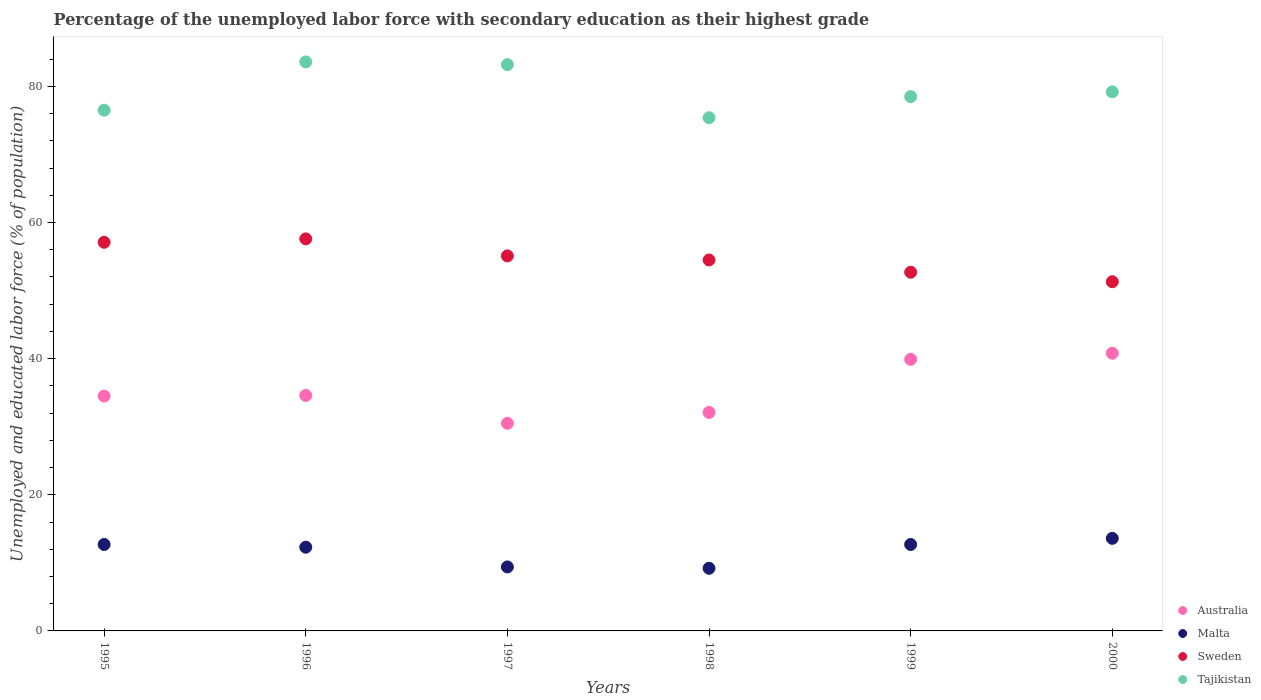How many different coloured dotlines are there?
Provide a succinct answer. 4. What is the percentage of the unemployed labor force with secondary education in Australia in 1997?
Your response must be concise. 30.5. Across all years, what is the maximum percentage of the unemployed labor force with secondary education in Australia?
Make the answer very short. 40.8. Across all years, what is the minimum percentage of the unemployed labor force with secondary education in Tajikistan?
Your answer should be very brief. 75.4. In which year was the percentage of the unemployed labor force with secondary education in Malta maximum?
Provide a succinct answer. 2000. What is the total percentage of the unemployed labor force with secondary education in Tajikistan in the graph?
Your response must be concise. 476.4. What is the difference between the percentage of the unemployed labor force with secondary education in Malta in 1996 and that in 1998?
Your answer should be compact. 3.1. What is the difference between the percentage of the unemployed labor force with secondary education in Tajikistan in 1998 and the percentage of the unemployed labor force with secondary education in Australia in 1997?
Your answer should be compact. 44.9. What is the average percentage of the unemployed labor force with secondary education in Tajikistan per year?
Ensure brevity in your answer.  79.4. In the year 1997, what is the difference between the percentage of the unemployed labor force with secondary education in Sweden and percentage of the unemployed labor force with secondary education in Australia?
Your answer should be very brief. 24.6. In how many years, is the percentage of the unemployed labor force with secondary education in Malta greater than 20 %?
Offer a very short reply. 0. What is the ratio of the percentage of the unemployed labor force with secondary education in Australia in 1995 to that in 1997?
Provide a short and direct response. 1.13. Is the difference between the percentage of the unemployed labor force with secondary education in Sweden in 1996 and 1997 greater than the difference between the percentage of the unemployed labor force with secondary education in Australia in 1996 and 1997?
Your answer should be compact. No. What is the difference between the highest and the second highest percentage of the unemployed labor force with secondary education in Malta?
Ensure brevity in your answer.  0.9. What is the difference between the highest and the lowest percentage of the unemployed labor force with secondary education in Sweden?
Offer a terse response. 6.3. In how many years, is the percentage of the unemployed labor force with secondary education in Sweden greater than the average percentage of the unemployed labor force with secondary education in Sweden taken over all years?
Keep it short and to the point. 3. Is the sum of the percentage of the unemployed labor force with secondary education in Australia in 1995 and 1998 greater than the maximum percentage of the unemployed labor force with secondary education in Sweden across all years?
Offer a terse response. Yes. Is it the case that in every year, the sum of the percentage of the unemployed labor force with secondary education in Australia and percentage of the unemployed labor force with secondary education in Malta  is greater than the sum of percentage of the unemployed labor force with secondary education in Tajikistan and percentage of the unemployed labor force with secondary education in Sweden?
Ensure brevity in your answer.  No. Is it the case that in every year, the sum of the percentage of the unemployed labor force with secondary education in Australia and percentage of the unemployed labor force with secondary education in Tajikistan  is greater than the percentage of the unemployed labor force with secondary education in Sweden?
Provide a succinct answer. Yes. Is the percentage of the unemployed labor force with secondary education in Sweden strictly less than the percentage of the unemployed labor force with secondary education in Malta over the years?
Provide a succinct answer. No. How many dotlines are there?
Give a very brief answer. 4. Does the graph contain grids?
Give a very brief answer. No. How are the legend labels stacked?
Provide a short and direct response. Vertical. What is the title of the graph?
Give a very brief answer. Percentage of the unemployed labor force with secondary education as their highest grade. What is the label or title of the X-axis?
Make the answer very short. Years. What is the label or title of the Y-axis?
Your answer should be compact. Unemployed and educated labor force (% of population). What is the Unemployed and educated labor force (% of population) of Australia in 1995?
Your answer should be very brief. 34.5. What is the Unemployed and educated labor force (% of population) of Malta in 1995?
Your response must be concise. 12.7. What is the Unemployed and educated labor force (% of population) of Sweden in 1995?
Offer a terse response. 57.1. What is the Unemployed and educated labor force (% of population) in Tajikistan in 1995?
Give a very brief answer. 76.5. What is the Unemployed and educated labor force (% of population) in Australia in 1996?
Provide a short and direct response. 34.6. What is the Unemployed and educated labor force (% of population) of Malta in 1996?
Your answer should be compact. 12.3. What is the Unemployed and educated labor force (% of population) of Sweden in 1996?
Offer a terse response. 57.6. What is the Unemployed and educated labor force (% of population) in Tajikistan in 1996?
Make the answer very short. 83.6. What is the Unemployed and educated labor force (% of population) of Australia in 1997?
Give a very brief answer. 30.5. What is the Unemployed and educated labor force (% of population) in Malta in 1997?
Provide a succinct answer. 9.4. What is the Unemployed and educated labor force (% of population) in Sweden in 1997?
Your response must be concise. 55.1. What is the Unemployed and educated labor force (% of population) in Tajikistan in 1997?
Give a very brief answer. 83.2. What is the Unemployed and educated labor force (% of population) of Australia in 1998?
Your response must be concise. 32.1. What is the Unemployed and educated labor force (% of population) of Malta in 1998?
Provide a succinct answer. 9.2. What is the Unemployed and educated labor force (% of population) of Sweden in 1998?
Your response must be concise. 54.5. What is the Unemployed and educated labor force (% of population) of Tajikistan in 1998?
Keep it short and to the point. 75.4. What is the Unemployed and educated labor force (% of population) of Australia in 1999?
Provide a succinct answer. 39.9. What is the Unemployed and educated labor force (% of population) of Malta in 1999?
Keep it short and to the point. 12.7. What is the Unemployed and educated labor force (% of population) of Sweden in 1999?
Your answer should be compact. 52.7. What is the Unemployed and educated labor force (% of population) in Tajikistan in 1999?
Your answer should be very brief. 78.5. What is the Unemployed and educated labor force (% of population) in Australia in 2000?
Provide a succinct answer. 40.8. What is the Unemployed and educated labor force (% of population) in Malta in 2000?
Provide a succinct answer. 13.6. What is the Unemployed and educated labor force (% of population) in Sweden in 2000?
Provide a succinct answer. 51.3. What is the Unemployed and educated labor force (% of population) of Tajikistan in 2000?
Give a very brief answer. 79.2. Across all years, what is the maximum Unemployed and educated labor force (% of population) in Australia?
Provide a short and direct response. 40.8. Across all years, what is the maximum Unemployed and educated labor force (% of population) of Malta?
Keep it short and to the point. 13.6. Across all years, what is the maximum Unemployed and educated labor force (% of population) in Sweden?
Make the answer very short. 57.6. Across all years, what is the maximum Unemployed and educated labor force (% of population) of Tajikistan?
Ensure brevity in your answer.  83.6. Across all years, what is the minimum Unemployed and educated labor force (% of population) in Australia?
Your answer should be compact. 30.5. Across all years, what is the minimum Unemployed and educated labor force (% of population) of Malta?
Your answer should be very brief. 9.2. Across all years, what is the minimum Unemployed and educated labor force (% of population) of Sweden?
Give a very brief answer. 51.3. Across all years, what is the minimum Unemployed and educated labor force (% of population) in Tajikistan?
Offer a very short reply. 75.4. What is the total Unemployed and educated labor force (% of population) of Australia in the graph?
Keep it short and to the point. 212.4. What is the total Unemployed and educated labor force (% of population) in Malta in the graph?
Offer a terse response. 69.9. What is the total Unemployed and educated labor force (% of population) in Sweden in the graph?
Offer a very short reply. 328.3. What is the total Unemployed and educated labor force (% of population) in Tajikistan in the graph?
Offer a very short reply. 476.4. What is the difference between the Unemployed and educated labor force (% of population) of Malta in 1995 and that in 1996?
Ensure brevity in your answer.  0.4. What is the difference between the Unemployed and educated labor force (% of population) of Sweden in 1995 and that in 1997?
Make the answer very short. 2. What is the difference between the Unemployed and educated labor force (% of population) in Tajikistan in 1995 and that in 1997?
Your response must be concise. -6.7. What is the difference between the Unemployed and educated labor force (% of population) of Australia in 1995 and that in 1998?
Ensure brevity in your answer.  2.4. What is the difference between the Unemployed and educated labor force (% of population) of Malta in 1995 and that in 1998?
Your answer should be very brief. 3.5. What is the difference between the Unemployed and educated labor force (% of population) in Sweden in 1995 and that in 1998?
Your answer should be very brief. 2.6. What is the difference between the Unemployed and educated labor force (% of population) of Australia in 1995 and that in 1999?
Offer a terse response. -5.4. What is the difference between the Unemployed and educated labor force (% of population) in Sweden in 1995 and that in 1999?
Give a very brief answer. 4.4. What is the difference between the Unemployed and educated labor force (% of population) of Tajikistan in 1995 and that in 1999?
Offer a terse response. -2. What is the difference between the Unemployed and educated labor force (% of population) in Malta in 1995 and that in 2000?
Keep it short and to the point. -0.9. What is the difference between the Unemployed and educated labor force (% of population) in Tajikistan in 1995 and that in 2000?
Offer a terse response. -2.7. What is the difference between the Unemployed and educated labor force (% of population) in Malta in 1996 and that in 1997?
Provide a succinct answer. 2.9. What is the difference between the Unemployed and educated labor force (% of population) in Sweden in 1996 and that in 1997?
Make the answer very short. 2.5. What is the difference between the Unemployed and educated labor force (% of population) in Malta in 1996 and that in 1998?
Offer a very short reply. 3.1. What is the difference between the Unemployed and educated labor force (% of population) in Sweden in 1996 and that in 1998?
Provide a succinct answer. 3.1. What is the difference between the Unemployed and educated labor force (% of population) in Tajikistan in 1996 and that in 1998?
Provide a short and direct response. 8.2. What is the difference between the Unemployed and educated labor force (% of population) of Malta in 1996 and that in 1999?
Your answer should be very brief. -0.4. What is the difference between the Unemployed and educated labor force (% of population) of Sweden in 1996 and that in 1999?
Offer a very short reply. 4.9. What is the difference between the Unemployed and educated labor force (% of population) of Tajikistan in 1996 and that in 1999?
Offer a terse response. 5.1. What is the difference between the Unemployed and educated labor force (% of population) in Australia in 1996 and that in 2000?
Make the answer very short. -6.2. What is the difference between the Unemployed and educated labor force (% of population) in Malta in 1996 and that in 2000?
Give a very brief answer. -1.3. What is the difference between the Unemployed and educated labor force (% of population) of Tajikistan in 1996 and that in 2000?
Provide a short and direct response. 4.4. What is the difference between the Unemployed and educated labor force (% of population) in Australia in 1997 and that in 1998?
Your answer should be very brief. -1.6. What is the difference between the Unemployed and educated labor force (% of population) of Sweden in 1997 and that in 1998?
Ensure brevity in your answer.  0.6. What is the difference between the Unemployed and educated labor force (% of population) of Tajikistan in 1997 and that in 1998?
Offer a very short reply. 7.8. What is the difference between the Unemployed and educated labor force (% of population) in Australia in 1997 and that in 1999?
Offer a very short reply. -9.4. What is the difference between the Unemployed and educated labor force (% of population) of Tajikistan in 1997 and that in 1999?
Offer a terse response. 4.7. What is the difference between the Unemployed and educated labor force (% of population) of Tajikistan in 1997 and that in 2000?
Give a very brief answer. 4. What is the difference between the Unemployed and educated labor force (% of population) of Australia in 1998 and that in 1999?
Offer a terse response. -7.8. What is the difference between the Unemployed and educated labor force (% of population) in Australia in 1998 and that in 2000?
Offer a very short reply. -8.7. What is the difference between the Unemployed and educated labor force (% of population) in Sweden in 1998 and that in 2000?
Ensure brevity in your answer.  3.2. What is the difference between the Unemployed and educated labor force (% of population) in Australia in 1999 and that in 2000?
Offer a terse response. -0.9. What is the difference between the Unemployed and educated labor force (% of population) of Malta in 1999 and that in 2000?
Ensure brevity in your answer.  -0.9. What is the difference between the Unemployed and educated labor force (% of population) of Australia in 1995 and the Unemployed and educated labor force (% of population) of Malta in 1996?
Keep it short and to the point. 22.2. What is the difference between the Unemployed and educated labor force (% of population) in Australia in 1995 and the Unemployed and educated labor force (% of population) in Sweden in 1996?
Make the answer very short. -23.1. What is the difference between the Unemployed and educated labor force (% of population) in Australia in 1995 and the Unemployed and educated labor force (% of population) in Tajikistan in 1996?
Offer a very short reply. -49.1. What is the difference between the Unemployed and educated labor force (% of population) in Malta in 1995 and the Unemployed and educated labor force (% of population) in Sweden in 1996?
Offer a very short reply. -44.9. What is the difference between the Unemployed and educated labor force (% of population) of Malta in 1995 and the Unemployed and educated labor force (% of population) of Tajikistan in 1996?
Ensure brevity in your answer.  -70.9. What is the difference between the Unemployed and educated labor force (% of population) of Sweden in 1995 and the Unemployed and educated labor force (% of population) of Tajikistan in 1996?
Your answer should be compact. -26.5. What is the difference between the Unemployed and educated labor force (% of population) in Australia in 1995 and the Unemployed and educated labor force (% of population) in Malta in 1997?
Ensure brevity in your answer.  25.1. What is the difference between the Unemployed and educated labor force (% of population) in Australia in 1995 and the Unemployed and educated labor force (% of population) in Sweden in 1997?
Give a very brief answer. -20.6. What is the difference between the Unemployed and educated labor force (% of population) of Australia in 1995 and the Unemployed and educated labor force (% of population) of Tajikistan in 1997?
Your response must be concise. -48.7. What is the difference between the Unemployed and educated labor force (% of population) of Malta in 1995 and the Unemployed and educated labor force (% of population) of Sweden in 1997?
Keep it short and to the point. -42.4. What is the difference between the Unemployed and educated labor force (% of population) in Malta in 1995 and the Unemployed and educated labor force (% of population) in Tajikistan in 1997?
Provide a succinct answer. -70.5. What is the difference between the Unemployed and educated labor force (% of population) of Sweden in 1995 and the Unemployed and educated labor force (% of population) of Tajikistan in 1997?
Offer a very short reply. -26.1. What is the difference between the Unemployed and educated labor force (% of population) of Australia in 1995 and the Unemployed and educated labor force (% of population) of Malta in 1998?
Give a very brief answer. 25.3. What is the difference between the Unemployed and educated labor force (% of population) of Australia in 1995 and the Unemployed and educated labor force (% of population) of Sweden in 1998?
Your answer should be very brief. -20. What is the difference between the Unemployed and educated labor force (% of population) of Australia in 1995 and the Unemployed and educated labor force (% of population) of Tajikistan in 1998?
Keep it short and to the point. -40.9. What is the difference between the Unemployed and educated labor force (% of population) in Malta in 1995 and the Unemployed and educated labor force (% of population) in Sweden in 1998?
Give a very brief answer. -41.8. What is the difference between the Unemployed and educated labor force (% of population) of Malta in 1995 and the Unemployed and educated labor force (% of population) of Tajikistan in 1998?
Offer a terse response. -62.7. What is the difference between the Unemployed and educated labor force (% of population) in Sweden in 1995 and the Unemployed and educated labor force (% of population) in Tajikistan in 1998?
Offer a very short reply. -18.3. What is the difference between the Unemployed and educated labor force (% of population) in Australia in 1995 and the Unemployed and educated labor force (% of population) in Malta in 1999?
Offer a very short reply. 21.8. What is the difference between the Unemployed and educated labor force (% of population) of Australia in 1995 and the Unemployed and educated labor force (% of population) of Sweden in 1999?
Keep it short and to the point. -18.2. What is the difference between the Unemployed and educated labor force (% of population) in Australia in 1995 and the Unemployed and educated labor force (% of population) in Tajikistan in 1999?
Offer a very short reply. -44. What is the difference between the Unemployed and educated labor force (% of population) of Malta in 1995 and the Unemployed and educated labor force (% of population) of Sweden in 1999?
Provide a short and direct response. -40. What is the difference between the Unemployed and educated labor force (% of population) in Malta in 1995 and the Unemployed and educated labor force (% of population) in Tajikistan in 1999?
Make the answer very short. -65.8. What is the difference between the Unemployed and educated labor force (% of population) in Sweden in 1995 and the Unemployed and educated labor force (% of population) in Tajikistan in 1999?
Keep it short and to the point. -21.4. What is the difference between the Unemployed and educated labor force (% of population) of Australia in 1995 and the Unemployed and educated labor force (% of population) of Malta in 2000?
Make the answer very short. 20.9. What is the difference between the Unemployed and educated labor force (% of population) in Australia in 1995 and the Unemployed and educated labor force (% of population) in Sweden in 2000?
Your answer should be very brief. -16.8. What is the difference between the Unemployed and educated labor force (% of population) of Australia in 1995 and the Unemployed and educated labor force (% of population) of Tajikistan in 2000?
Your answer should be very brief. -44.7. What is the difference between the Unemployed and educated labor force (% of population) of Malta in 1995 and the Unemployed and educated labor force (% of population) of Sweden in 2000?
Your answer should be very brief. -38.6. What is the difference between the Unemployed and educated labor force (% of population) of Malta in 1995 and the Unemployed and educated labor force (% of population) of Tajikistan in 2000?
Your answer should be very brief. -66.5. What is the difference between the Unemployed and educated labor force (% of population) of Sweden in 1995 and the Unemployed and educated labor force (% of population) of Tajikistan in 2000?
Your response must be concise. -22.1. What is the difference between the Unemployed and educated labor force (% of population) of Australia in 1996 and the Unemployed and educated labor force (% of population) of Malta in 1997?
Give a very brief answer. 25.2. What is the difference between the Unemployed and educated labor force (% of population) in Australia in 1996 and the Unemployed and educated labor force (% of population) in Sweden in 1997?
Your answer should be compact. -20.5. What is the difference between the Unemployed and educated labor force (% of population) of Australia in 1996 and the Unemployed and educated labor force (% of population) of Tajikistan in 1997?
Make the answer very short. -48.6. What is the difference between the Unemployed and educated labor force (% of population) in Malta in 1996 and the Unemployed and educated labor force (% of population) in Sweden in 1997?
Offer a terse response. -42.8. What is the difference between the Unemployed and educated labor force (% of population) in Malta in 1996 and the Unemployed and educated labor force (% of population) in Tajikistan in 1997?
Provide a succinct answer. -70.9. What is the difference between the Unemployed and educated labor force (% of population) of Sweden in 1996 and the Unemployed and educated labor force (% of population) of Tajikistan in 1997?
Provide a succinct answer. -25.6. What is the difference between the Unemployed and educated labor force (% of population) of Australia in 1996 and the Unemployed and educated labor force (% of population) of Malta in 1998?
Provide a succinct answer. 25.4. What is the difference between the Unemployed and educated labor force (% of population) of Australia in 1996 and the Unemployed and educated labor force (% of population) of Sweden in 1998?
Provide a short and direct response. -19.9. What is the difference between the Unemployed and educated labor force (% of population) in Australia in 1996 and the Unemployed and educated labor force (% of population) in Tajikistan in 1998?
Your response must be concise. -40.8. What is the difference between the Unemployed and educated labor force (% of population) of Malta in 1996 and the Unemployed and educated labor force (% of population) of Sweden in 1998?
Your answer should be very brief. -42.2. What is the difference between the Unemployed and educated labor force (% of population) in Malta in 1996 and the Unemployed and educated labor force (% of population) in Tajikistan in 1998?
Offer a terse response. -63.1. What is the difference between the Unemployed and educated labor force (% of population) in Sweden in 1996 and the Unemployed and educated labor force (% of population) in Tajikistan in 1998?
Your response must be concise. -17.8. What is the difference between the Unemployed and educated labor force (% of population) of Australia in 1996 and the Unemployed and educated labor force (% of population) of Malta in 1999?
Provide a short and direct response. 21.9. What is the difference between the Unemployed and educated labor force (% of population) in Australia in 1996 and the Unemployed and educated labor force (% of population) in Sweden in 1999?
Make the answer very short. -18.1. What is the difference between the Unemployed and educated labor force (% of population) of Australia in 1996 and the Unemployed and educated labor force (% of population) of Tajikistan in 1999?
Your answer should be very brief. -43.9. What is the difference between the Unemployed and educated labor force (% of population) of Malta in 1996 and the Unemployed and educated labor force (% of population) of Sweden in 1999?
Your answer should be very brief. -40.4. What is the difference between the Unemployed and educated labor force (% of population) in Malta in 1996 and the Unemployed and educated labor force (% of population) in Tajikistan in 1999?
Your response must be concise. -66.2. What is the difference between the Unemployed and educated labor force (% of population) in Sweden in 1996 and the Unemployed and educated labor force (% of population) in Tajikistan in 1999?
Provide a succinct answer. -20.9. What is the difference between the Unemployed and educated labor force (% of population) in Australia in 1996 and the Unemployed and educated labor force (% of population) in Sweden in 2000?
Make the answer very short. -16.7. What is the difference between the Unemployed and educated labor force (% of population) in Australia in 1996 and the Unemployed and educated labor force (% of population) in Tajikistan in 2000?
Provide a succinct answer. -44.6. What is the difference between the Unemployed and educated labor force (% of population) in Malta in 1996 and the Unemployed and educated labor force (% of population) in Sweden in 2000?
Provide a short and direct response. -39. What is the difference between the Unemployed and educated labor force (% of population) of Malta in 1996 and the Unemployed and educated labor force (% of population) of Tajikistan in 2000?
Make the answer very short. -66.9. What is the difference between the Unemployed and educated labor force (% of population) of Sweden in 1996 and the Unemployed and educated labor force (% of population) of Tajikistan in 2000?
Offer a terse response. -21.6. What is the difference between the Unemployed and educated labor force (% of population) in Australia in 1997 and the Unemployed and educated labor force (% of population) in Malta in 1998?
Offer a terse response. 21.3. What is the difference between the Unemployed and educated labor force (% of population) in Australia in 1997 and the Unemployed and educated labor force (% of population) in Sweden in 1998?
Make the answer very short. -24. What is the difference between the Unemployed and educated labor force (% of population) of Australia in 1997 and the Unemployed and educated labor force (% of population) of Tajikistan in 1998?
Your answer should be compact. -44.9. What is the difference between the Unemployed and educated labor force (% of population) in Malta in 1997 and the Unemployed and educated labor force (% of population) in Sweden in 1998?
Give a very brief answer. -45.1. What is the difference between the Unemployed and educated labor force (% of population) in Malta in 1997 and the Unemployed and educated labor force (% of population) in Tajikistan in 1998?
Your answer should be compact. -66. What is the difference between the Unemployed and educated labor force (% of population) of Sweden in 1997 and the Unemployed and educated labor force (% of population) of Tajikistan in 1998?
Offer a terse response. -20.3. What is the difference between the Unemployed and educated labor force (% of population) in Australia in 1997 and the Unemployed and educated labor force (% of population) in Sweden in 1999?
Provide a succinct answer. -22.2. What is the difference between the Unemployed and educated labor force (% of population) in Australia in 1997 and the Unemployed and educated labor force (% of population) in Tajikistan in 1999?
Offer a terse response. -48. What is the difference between the Unemployed and educated labor force (% of population) of Malta in 1997 and the Unemployed and educated labor force (% of population) of Sweden in 1999?
Provide a succinct answer. -43.3. What is the difference between the Unemployed and educated labor force (% of population) of Malta in 1997 and the Unemployed and educated labor force (% of population) of Tajikistan in 1999?
Make the answer very short. -69.1. What is the difference between the Unemployed and educated labor force (% of population) of Sweden in 1997 and the Unemployed and educated labor force (% of population) of Tajikistan in 1999?
Keep it short and to the point. -23.4. What is the difference between the Unemployed and educated labor force (% of population) in Australia in 1997 and the Unemployed and educated labor force (% of population) in Sweden in 2000?
Offer a very short reply. -20.8. What is the difference between the Unemployed and educated labor force (% of population) of Australia in 1997 and the Unemployed and educated labor force (% of population) of Tajikistan in 2000?
Keep it short and to the point. -48.7. What is the difference between the Unemployed and educated labor force (% of population) of Malta in 1997 and the Unemployed and educated labor force (% of population) of Sweden in 2000?
Offer a terse response. -41.9. What is the difference between the Unemployed and educated labor force (% of population) in Malta in 1997 and the Unemployed and educated labor force (% of population) in Tajikistan in 2000?
Offer a very short reply. -69.8. What is the difference between the Unemployed and educated labor force (% of population) in Sweden in 1997 and the Unemployed and educated labor force (% of population) in Tajikistan in 2000?
Give a very brief answer. -24.1. What is the difference between the Unemployed and educated labor force (% of population) of Australia in 1998 and the Unemployed and educated labor force (% of population) of Sweden in 1999?
Keep it short and to the point. -20.6. What is the difference between the Unemployed and educated labor force (% of population) in Australia in 1998 and the Unemployed and educated labor force (% of population) in Tajikistan in 1999?
Keep it short and to the point. -46.4. What is the difference between the Unemployed and educated labor force (% of population) in Malta in 1998 and the Unemployed and educated labor force (% of population) in Sweden in 1999?
Ensure brevity in your answer.  -43.5. What is the difference between the Unemployed and educated labor force (% of population) of Malta in 1998 and the Unemployed and educated labor force (% of population) of Tajikistan in 1999?
Your response must be concise. -69.3. What is the difference between the Unemployed and educated labor force (% of population) in Sweden in 1998 and the Unemployed and educated labor force (% of population) in Tajikistan in 1999?
Give a very brief answer. -24. What is the difference between the Unemployed and educated labor force (% of population) in Australia in 1998 and the Unemployed and educated labor force (% of population) in Sweden in 2000?
Your response must be concise. -19.2. What is the difference between the Unemployed and educated labor force (% of population) in Australia in 1998 and the Unemployed and educated labor force (% of population) in Tajikistan in 2000?
Give a very brief answer. -47.1. What is the difference between the Unemployed and educated labor force (% of population) in Malta in 1998 and the Unemployed and educated labor force (% of population) in Sweden in 2000?
Provide a short and direct response. -42.1. What is the difference between the Unemployed and educated labor force (% of population) in Malta in 1998 and the Unemployed and educated labor force (% of population) in Tajikistan in 2000?
Provide a succinct answer. -70. What is the difference between the Unemployed and educated labor force (% of population) in Sweden in 1998 and the Unemployed and educated labor force (% of population) in Tajikistan in 2000?
Keep it short and to the point. -24.7. What is the difference between the Unemployed and educated labor force (% of population) of Australia in 1999 and the Unemployed and educated labor force (% of population) of Malta in 2000?
Keep it short and to the point. 26.3. What is the difference between the Unemployed and educated labor force (% of population) of Australia in 1999 and the Unemployed and educated labor force (% of population) of Tajikistan in 2000?
Your answer should be compact. -39.3. What is the difference between the Unemployed and educated labor force (% of population) of Malta in 1999 and the Unemployed and educated labor force (% of population) of Sweden in 2000?
Provide a short and direct response. -38.6. What is the difference between the Unemployed and educated labor force (% of population) of Malta in 1999 and the Unemployed and educated labor force (% of population) of Tajikistan in 2000?
Ensure brevity in your answer.  -66.5. What is the difference between the Unemployed and educated labor force (% of population) of Sweden in 1999 and the Unemployed and educated labor force (% of population) of Tajikistan in 2000?
Make the answer very short. -26.5. What is the average Unemployed and educated labor force (% of population) in Australia per year?
Offer a terse response. 35.4. What is the average Unemployed and educated labor force (% of population) in Malta per year?
Ensure brevity in your answer.  11.65. What is the average Unemployed and educated labor force (% of population) in Sweden per year?
Keep it short and to the point. 54.72. What is the average Unemployed and educated labor force (% of population) of Tajikistan per year?
Your response must be concise. 79.4. In the year 1995, what is the difference between the Unemployed and educated labor force (% of population) in Australia and Unemployed and educated labor force (% of population) in Malta?
Offer a terse response. 21.8. In the year 1995, what is the difference between the Unemployed and educated labor force (% of population) of Australia and Unemployed and educated labor force (% of population) of Sweden?
Provide a short and direct response. -22.6. In the year 1995, what is the difference between the Unemployed and educated labor force (% of population) in Australia and Unemployed and educated labor force (% of population) in Tajikistan?
Your answer should be very brief. -42. In the year 1995, what is the difference between the Unemployed and educated labor force (% of population) in Malta and Unemployed and educated labor force (% of population) in Sweden?
Your response must be concise. -44.4. In the year 1995, what is the difference between the Unemployed and educated labor force (% of population) in Malta and Unemployed and educated labor force (% of population) in Tajikistan?
Offer a terse response. -63.8. In the year 1995, what is the difference between the Unemployed and educated labor force (% of population) in Sweden and Unemployed and educated labor force (% of population) in Tajikistan?
Provide a succinct answer. -19.4. In the year 1996, what is the difference between the Unemployed and educated labor force (% of population) in Australia and Unemployed and educated labor force (% of population) in Malta?
Your response must be concise. 22.3. In the year 1996, what is the difference between the Unemployed and educated labor force (% of population) in Australia and Unemployed and educated labor force (% of population) in Tajikistan?
Offer a terse response. -49. In the year 1996, what is the difference between the Unemployed and educated labor force (% of population) in Malta and Unemployed and educated labor force (% of population) in Sweden?
Keep it short and to the point. -45.3. In the year 1996, what is the difference between the Unemployed and educated labor force (% of population) in Malta and Unemployed and educated labor force (% of population) in Tajikistan?
Your answer should be compact. -71.3. In the year 1997, what is the difference between the Unemployed and educated labor force (% of population) in Australia and Unemployed and educated labor force (% of population) in Malta?
Give a very brief answer. 21.1. In the year 1997, what is the difference between the Unemployed and educated labor force (% of population) of Australia and Unemployed and educated labor force (% of population) of Sweden?
Provide a succinct answer. -24.6. In the year 1997, what is the difference between the Unemployed and educated labor force (% of population) of Australia and Unemployed and educated labor force (% of population) of Tajikistan?
Provide a succinct answer. -52.7. In the year 1997, what is the difference between the Unemployed and educated labor force (% of population) in Malta and Unemployed and educated labor force (% of population) in Sweden?
Provide a short and direct response. -45.7. In the year 1997, what is the difference between the Unemployed and educated labor force (% of population) in Malta and Unemployed and educated labor force (% of population) in Tajikistan?
Make the answer very short. -73.8. In the year 1997, what is the difference between the Unemployed and educated labor force (% of population) in Sweden and Unemployed and educated labor force (% of population) in Tajikistan?
Make the answer very short. -28.1. In the year 1998, what is the difference between the Unemployed and educated labor force (% of population) of Australia and Unemployed and educated labor force (% of population) of Malta?
Offer a terse response. 22.9. In the year 1998, what is the difference between the Unemployed and educated labor force (% of population) of Australia and Unemployed and educated labor force (% of population) of Sweden?
Keep it short and to the point. -22.4. In the year 1998, what is the difference between the Unemployed and educated labor force (% of population) in Australia and Unemployed and educated labor force (% of population) in Tajikistan?
Provide a short and direct response. -43.3. In the year 1998, what is the difference between the Unemployed and educated labor force (% of population) of Malta and Unemployed and educated labor force (% of population) of Sweden?
Offer a terse response. -45.3. In the year 1998, what is the difference between the Unemployed and educated labor force (% of population) in Malta and Unemployed and educated labor force (% of population) in Tajikistan?
Keep it short and to the point. -66.2. In the year 1998, what is the difference between the Unemployed and educated labor force (% of population) of Sweden and Unemployed and educated labor force (% of population) of Tajikistan?
Your response must be concise. -20.9. In the year 1999, what is the difference between the Unemployed and educated labor force (% of population) of Australia and Unemployed and educated labor force (% of population) of Malta?
Make the answer very short. 27.2. In the year 1999, what is the difference between the Unemployed and educated labor force (% of population) in Australia and Unemployed and educated labor force (% of population) in Sweden?
Offer a very short reply. -12.8. In the year 1999, what is the difference between the Unemployed and educated labor force (% of population) of Australia and Unemployed and educated labor force (% of population) of Tajikistan?
Ensure brevity in your answer.  -38.6. In the year 1999, what is the difference between the Unemployed and educated labor force (% of population) of Malta and Unemployed and educated labor force (% of population) of Sweden?
Provide a succinct answer. -40. In the year 1999, what is the difference between the Unemployed and educated labor force (% of population) in Malta and Unemployed and educated labor force (% of population) in Tajikistan?
Provide a short and direct response. -65.8. In the year 1999, what is the difference between the Unemployed and educated labor force (% of population) in Sweden and Unemployed and educated labor force (% of population) in Tajikistan?
Provide a succinct answer. -25.8. In the year 2000, what is the difference between the Unemployed and educated labor force (% of population) of Australia and Unemployed and educated labor force (% of population) of Malta?
Your answer should be very brief. 27.2. In the year 2000, what is the difference between the Unemployed and educated labor force (% of population) of Australia and Unemployed and educated labor force (% of population) of Tajikistan?
Make the answer very short. -38.4. In the year 2000, what is the difference between the Unemployed and educated labor force (% of population) of Malta and Unemployed and educated labor force (% of population) of Sweden?
Ensure brevity in your answer.  -37.7. In the year 2000, what is the difference between the Unemployed and educated labor force (% of population) of Malta and Unemployed and educated labor force (% of population) of Tajikistan?
Keep it short and to the point. -65.6. In the year 2000, what is the difference between the Unemployed and educated labor force (% of population) of Sweden and Unemployed and educated labor force (% of population) of Tajikistan?
Provide a succinct answer. -27.9. What is the ratio of the Unemployed and educated labor force (% of population) of Malta in 1995 to that in 1996?
Offer a very short reply. 1.03. What is the ratio of the Unemployed and educated labor force (% of population) in Tajikistan in 1995 to that in 1996?
Provide a short and direct response. 0.92. What is the ratio of the Unemployed and educated labor force (% of population) in Australia in 1995 to that in 1997?
Your answer should be very brief. 1.13. What is the ratio of the Unemployed and educated labor force (% of population) of Malta in 1995 to that in 1997?
Provide a succinct answer. 1.35. What is the ratio of the Unemployed and educated labor force (% of population) in Sweden in 1995 to that in 1997?
Keep it short and to the point. 1.04. What is the ratio of the Unemployed and educated labor force (% of population) of Tajikistan in 1995 to that in 1997?
Offer a terse response. 0.92. What is the ratio of the Unemployed and educated labor force (% of population) in Australia in 1995 to that in 1998?
Make the answer very short. 1.07. What is the ratio of the Unemployed and educated labor force (% of population) in Malta in 1995 to that in 1998?
Your answer should be very brief. 1.38. What is the ratio of the Unemployed and educated labor force (% of population) in Sweden in 1995 to that in 1998?
Give a very brief answer. 1.05. What is the ratio of the Unemployed and educated labor force (% of population) of Tajikistan in 1995 to that in 1998?
Keep it short and to the point. 1.01. What is the ratio of the Unemployed and educated labor force (% of population) in Australia in 1995 to that in 1999?
Keep it short and to the point. 0.86. What is the ratio of the Unemployed and educated labor force (% of population) in Malta in 1995 to that in 1999?
Provide a short and direct response. 1. What is the ratio of the Unemployed and educated labor force (% of population) in Sweden in 1995 to that in 1999?
Provide a succinct answer. 1.08. What is the ratio of the Unemployed and educated labor force (% of population) in Tajikistan in 1995 to that in 1999?
Give a very brief answer. 0.97. What is the ratio of the Unemployed and educated labor force (% of population) of Australia in 1995 to that in 2000?
Provide a succinct answer. 0.85. What is the ratio of the Unemployed and educated labor force (% of population) in Malta in 1995 to that in 2000?
Offer a very short reply. 0.93. What is the ratio of the Unemployed and educated labor force (% of population) of Sweden in 1995 to that in 2000?
Provide a short and direct response. 1.11. What is the ratio of the Unemployed and educated labor force (% of population) of Tajikistan in 1995 to that in 2000?
Make the answer very short. 0.97. What is the ratio of the Unemployed and educated labor force (% of population) of Australia in 1996 to that in 1997?
Give a very brief answer. 1.13. What is the ratio of the Unemployed and educated labor force (% of population) of Malta in 1996 to that in 1997?
Ensure brevity in your answer.  1.31. What is the ratio of the Unemployed and educated labor force (% of population) in Sweden in 1996 to that in 1997?
Your answer should be very brief. 1.05. What is the ratio of the Unemployed and educated labor force (% of population) in Australia in 1996 to that in 1998?
Offer a very short reply. 1.08. What is the ratio of the Unemployed and educated labor force (% of population) in Malta in 1996 to that in 1998?
Give a very brief answer. 1.34. What is the ratio of the Unemployed and educated labor force (% of population) in Sweden in 1996 to that in 1998?
Ensure brevity in your answer.  1.06. What is the ratio of the Unemployed and educated labor force (% of population) in Tajikistan in 1996 to that in 1998?
Ensure brevity in your answer.  1.11. What is the ratio of the Unemployed and educated labor force (% of population) in Australia in 1996 to that in 1999?
Your answer should be compact. 0.87. What is the ratio of the Unemployed and educated labor force (% of population) of Malta in 1996 to that in 1999?
Your answer should be very brief. 0.97. What is the ratio of the Unemployed and educated labor force (% of population) in Sweden in 1996 to that in 1999?
Keep it short and to the point. 1.09. What is the ratio of the Unemployed and educated labor force (% of population) of Tajikistan in 1996 to that in 1999?
Ensure brevity in your answer.  1.06. What is the ratio of the Unemployed and educated labor force (% of population) of Australia in 1996 to that in 2000?
Make the answer very short. 0.85. What is the ratio of the Unemployed and educated labor force (% of population) in Malta in 1996 to that in 2000?
Your response must be concise. 0.9. What is the ratio of the Unemployed and educated labor force (% of population) of Sweden in 1996 to that in 2000?
Your response must be concise. 1.12. What is the ratio of the Unemployed and educated labor force (% of population) of Tajikistan in 1996 to that in 2000?
Offer a terse response. 1.06. What is the ratio of the Unemployed and educated labor force (% of population) in Australia in 1997 to that in 1998?
Keep it short and to the point. 0.95. What is the ratio of the Unemployed and educated labor force (% of population) in Malta in 1997 to that in 1998?
Your answer should be compact. 1.02. What is the ratio of the Unemployed and educated labor force (% of population) of Tajikistan in 1997 to that in 1998?
Your response must be concise. 1.1. What is the ratio of the Unemployed and educated labor force (% of population) of Australia in 1997 to that in 1999?
Make the answer very short. 0.76. What is the ratio of the Unemployed and educated labor force (% of population) in Malta in 1997 to that in 1999?
Your answer should be compact. 0.74. What is the ratio of the Unemployed and educated labor force (% of population) in Sweden in 1997 to that in 1999?
Offer a very short reply. 1.05. What is the ratio of the Unemployed and educated labor force (% of population) in Tajikistan in 1997 to that in 1999?
Provide a succinct answer. 1.06. What is the ratio of the Unemployed and educated labor force (% of population) in Australia in 1997 to that in 2000?
Offer a terse response. 0.75. What is the ratio of the Unemployed and educated labor force (% of population) in Malta in 1997 to that in 2000?
Offer a terse response. 0.69. What is the ratio of the Unemployed and educated labor force (% of population) of Sweden in 1997 to that in 2000?
Offer a very short reply. 1.07. What is the ratio of the Unemployed and educated labor force (% of population) of Tajikistan in 1997 to that in 2000?
Make the answer very short. 1.05. What is the ratio of the Unemployed and educated labor force (% of population) of Australia in 1998 to that in 1999?
Your response must be concise. 0.8. What is the ratio of the Unemployed and educated labor force (% of population) in Malta in 1998 to that in 1999?
Keep it short and to the point. 0.72. What is the ratio of the Unemployed and educated labor force (% of population) in Sweden in 1998 to that in 1999?
Your response must be concise. 1.03. What is the ratio of the Unemployed and educated labor force (% of population) in Tajikistan in 1998 to that in 1999?
Provide a succinct answer. 0.96. What is the ratio of the Unemployed and educated labor force (% of population) of Australia in 1998 to that in 2000?
Offer a terse response. 0.79. What is the ratio of the Unemployed and educated labor force (% of population) of Malta in 1998 to that in 2000?
Make the answer very short. 0.68. What is the ratio of the Unemployed and educated labor force (% of population) in Sweden in 1998 to that in 2000?
Make the answer very short. 1.06. What is the ratio of the Unemployed and educated labor force (% of population) of Tajikistan in 1998 to that in 2000?
Your answer should be very brief. 0.95. What is the ratio of the Unemployed and educated labor force (% of population) of Australia in 1999 to that in 2000?
Your response must be concise. 0.98. What is the ratio of the Unemployed and educated labor force (% of population) in Malta in 1999 to that in 2000?
Make the answer very short. 0.93. What is the ratio of the Unemployed and educated labor force (% of population) in Sweden in 1999 to that in 2000?
Your response must be concise. 1.03. What is the ratio of the Unemployed and educated labor force (% of population) of Tajikistan in 1999 to that in 2000?
Give a very brief answer. 0.99. What is the difference between the highest and the second highest Unemployed and educated labor force (% of population) of Australia?
Offer a terse response. 0.9. What is the difference between the highest and the second highest Unemployed and educated labor force (% of population) of Tajikistan?
Provide a short and direct response. 0.4. What is the difference between the highest and the lowest Unemployed and educated labor force (% of population) in Australia?
Offer a terse response. 10.3. What is the difference between the highest and the lowest Unemployed and educated labor force (% of population) of Malta?
Keep it short and to the point. 4.4. 